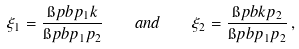Convert formula to latex. <formula><loc_0><loc_0><loc_500><loc_500>\xi _ { 1 } = \frac { \i p b { p _ { 1 } } { k } } { \i p b { p _ { 1 } } { p _ { 2 } } } \quad a n d \quad \xi _ { 2 } = \frac { \i p b { k } { p _ { 2 } } } { \i p b { p _ { 1 } } { p _ { 2 } } } \, ,</formula> 